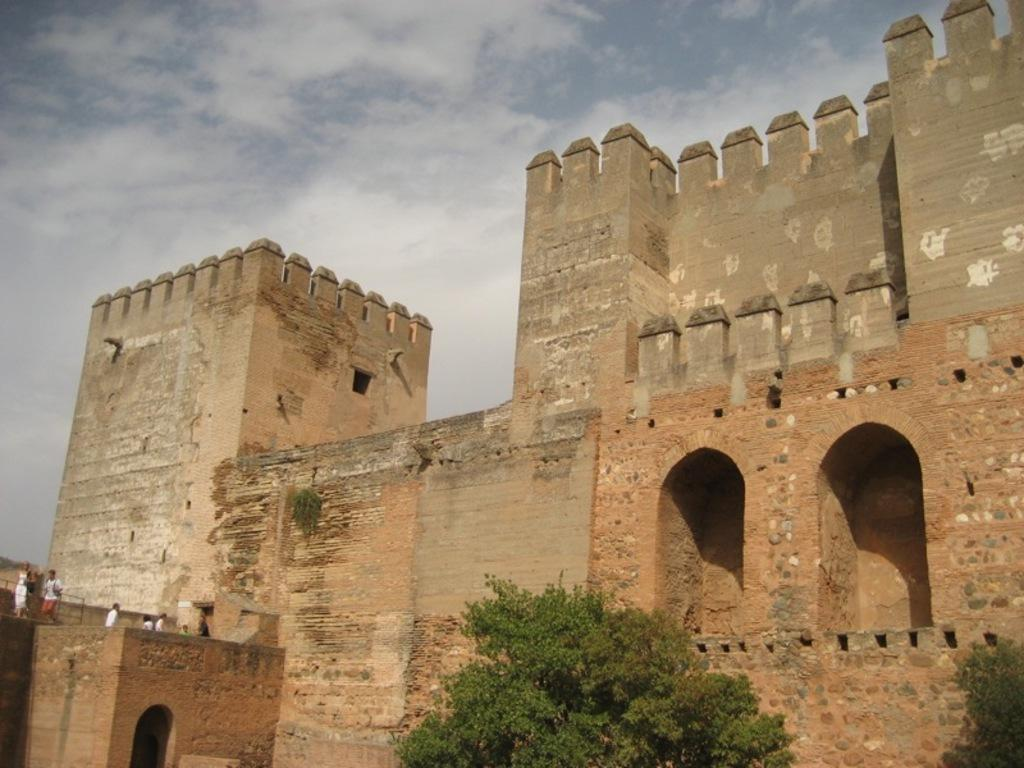What type of vegetation can be seen in the image? There are trees in the image. What is the color of the trees? The trees are green in color. What structure is present in the image? There is a fort in the image. What colors are used for the fort? The fort is brown and grey in color. What are the people on the fort doing? The people are standing on the fort. What can be seen in the background of the image? The sky is visible in the background of the image. Can you tell me how many mice are hiding in the office in the image? There is no office or mice present in the image; it features trees, a fort, and people. What type of room is depicted in the image? There is no room depicted in the image; it features trees, a fort, and people. 